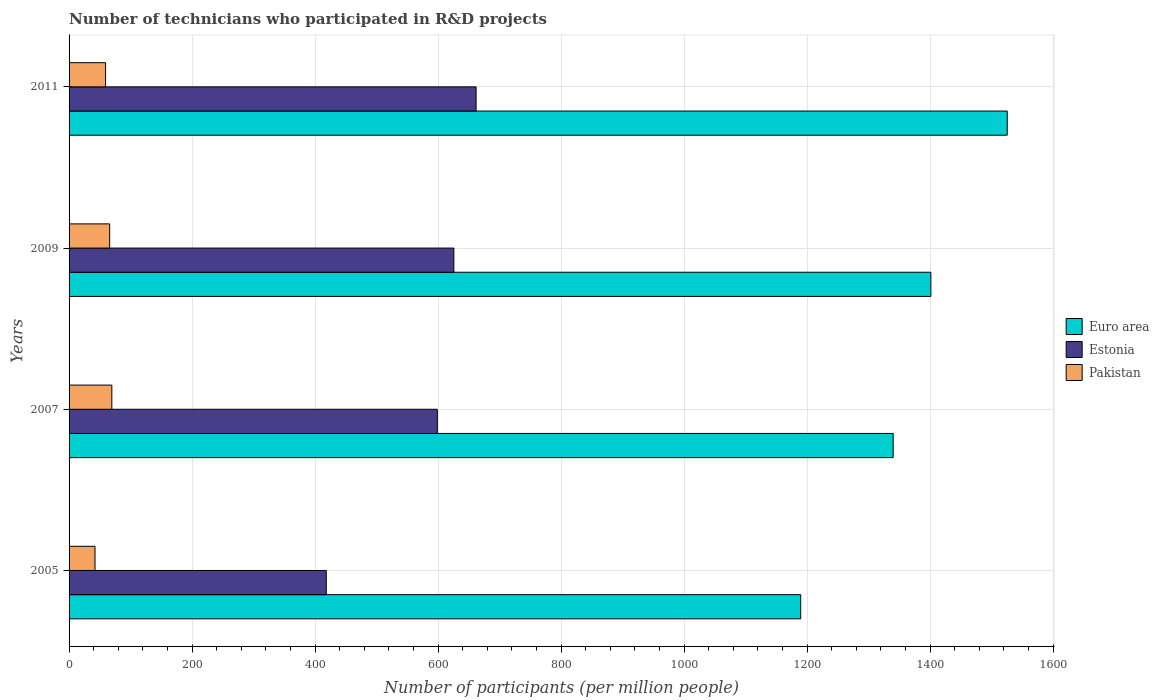How many different coloured bars are there?
Keep it short and to the point. 3. What is the label of the 4th group of bars from the top?
Keep it short and to the point. 2005. What is the number of technicians who participated in R&D projects in Euro area in 2011?
Your answer should be compact. 1525.59. Across all years, what is the maximum number of technicians who participated in R&D projects in Pakistan?
Your response must be concise. 69.56. Across all years, what is the minimum number of technicians who participated in R&D projects in Estonia?
Make the answer very short. 418.25. What is the total number of technicians who participated in R&D projects in Estonia in the graph?
Ensure brevity in your answer.  2304.71. What is the difference between the number of technicians who participated in R&D projects in Pakistan in 2007 and that in 2011?
Your response must be concise. 10.23. What is the difference between the number of technicians who participated in R&D projects in Euro area in 2009 and the number of technicians who participated in R&D projects in Pakistan in 2011?
Ensure brevity in your answer.  1342.06. What is the average number of technicians who participated in R&D projects in Pakistan per year?
Your answer should be compact. 59.27. In the year 2007, what is the difference between the number of technicians who participated in R&D projects in Pakistan and number of technicians who participated in R&D projects in Estonia?
Your response must be concise. -529.3. In how many years, is the number of technicians who participated in R&D projects in Estonia greater than 120 ?
Your answer should be very brief. 4. What is the ratio of the number of technicians who participated in R&D projects in Estonia in 2005 to that in 2011?
Make the answer very short. 0.63. Is the number of technicians who participated in R&D projects in Estonia in 2005 less than that in 2009?
Provide a succinct answer. Yes. What is the difference between the highest and the second highest number of technicians who participated in R&D projects in Euro area?
Offer a very short reply. 124.2. What is the difference between the highest and the lowest number of technicians who participated in R&D projects in Pakistan?
Keep it short and to the point. 27.36. What does the 3rd bar from the top in 2009 represents?
Provide a short and direct response. Euro area. What does the 2nd bar from the bottom in 2011 represents?
Your response must be concise. Estonia. How many years are there in the graph?
Your answer should be compact. 4. What is the difference between two consecutive major ticks on the X-axis?
Give a very brief answer. 200. Are the values on the major ticks of X-axis written in scientific E-notation?
Provide a succinct answer. No. Does the graph contain any zero values?
Give a very brief answer. No. Where does the legend appear in the graph?
Your answer should be compact. Center right. What is the title of the graph?
Make the answer very short. Number of technicians who participated in R&D projects. What is the label or title of the X-axis?
Your answer should be compact. Number of participants (per million people). What is the Number of participants (per million people) of Euro area in 2005?
Your answer should be very brief. 1189.74. What is the Number of participants (per million people) in Estonia in 2005?
Provide a succinct answer. 418.25. What is the Number of participants (per million people) of Pakistan in 2005?
Offer a terse response. 42.2. What is the Number of participants (per million people) of Euro area in 2007?
Ensure brevity in your answer.  1340.09. What is the Number of participants (per million people) of Estonia in 2007?
Your response must be concise. 598.85. What is the Number of participants (per million people) of Pakistan in 2007?
Your answer should be compact. 69.56. What is the Number of participants (per million people) of Euro area in 2009?
Provide a short and direct response. 1401.39. What is the Number of participants (per million people) of Estonia in 2009?
Make the answer very short. 625.74. What is the Number of participants (per million people) of Pakistan in 2009?
Give a very brief answer. 66.02. What is the Number of participants (per million people) in Euro area in 2011?
Your answer should be very brief. 1525.59. What is the Number of participants (per million people) in Estonia in 2011?
Give a very brief answer. 661.86. What is the Number of participants (per million people) of Pakistan in 2011?
Provide a short and direct response. 59.33. Across all years, what is the maximum Number of participants (per million people) of Euro area?
Make the answer very short. 1525.59. Across all years, what is the maximum Number of participants (per million people) in Estonia?
Keep it short and to the point. 661.86. Across all years, what is the maximum Number of participants (per million people) of Pakistan?
Provide a succinct answer. 69.56. Across all years, what is the minimum Number of participants (per million people) in Euro area?
Make the answer very short. 1189.74. Across all years, what is the minimum Number of participants (per million people) of Estonia?
Ensure brevity in your answer.  418.25. Across all years, what is the minimum Number of participants (per million people) of Pakistan?
Offer a very short reply. 42.2. What is the total Number of participants (per million people) in Euro area in the graph?
Offer a very short reply. 5456.81. What is the total Number of participants (per million people) in Estonia in the graph?
Give a very brief answer. 2304.71. What is the total Number of participants (per million people) of Pakistan in the graph?
Provide a succinct answer. 237.1. What is the difference between the Number of participants (per million people) of Euro area in 2005 and that in 2007?
Provide a succinct answer. -150.35. What is the difference between the Number of participants (per million people) in Estonia in 2005 and that in 2007?
Your response must be concise. -180.61. What is the difference between the Number of participants (per million people) of Pakistan in 2005 and that in 2007?
Provide a short and direct response. -27.36. What is the difference between the Number of participants (per million people) of Euro area in 2005 and that in 2009?
Give a very brief answer. -211.65. What is the difference between the Number of participants (per million people) in Estonia in 2005 and that in 2009?
Your response must be concise. -207.5. What is the difference between the Number of participants (per million people) of Pakistan in 2005 and that in 2009?
Provide a short and direct response. -23.82. What is the difference between the Number of participants (per million people) of Euro area in 2005 and that in 2011?
Offer a very short reply. -335.85. What is the difference between the Number of participants (per million people) of Estonia in 2005 and that in 2011?
Keep it short and to the point. -243.62. What is the difference between the Number of participants (per million people) of Pakistan in 2005 and that in 2011?
Offer a very short reply. -17.14. What is the difference between the Number of participants (per million people) of Euro area in 2007 and that in 2009?
Your answer should be compact. -61.3. What is the difference between the Number of participants (per million people) in Estonia in 2007 and that in 2009?
Offer a terse response. -26.89. What is the difference between the Number of participants (per million people) in Pakistan in 2007 and that in 2009?
Give a very brief answer. 3.54. What is the difference between the Number of participants (per million people) in Euro area in 2007 and that in 2011?
Make the answer very short. -185.49. What is the difference between the Number of participants (per million people) of Estonia in 2007 and that in 2011?
Your answer should be compact. -63.01. What is the difference between the Number of participants (per million people) of Pakistan in 2007 and that in 2011?
Provide a succinct answer. 10.23. What is the difference between the Number of participants (per million people) of Euro area in 2009 and that in 2011?
Provide a succinct answer. -124.2. What is the difference between the Number of participants (per million people) in Estonia in 2009 and that in 2011?
Your response must be concise. -36.12. What is the difference between the Number of participants (per million people) of Pakistan in 2009 and that in 2011?
Provide a short and direct response. 6.68. What is the difference between the Number of participants (per million people) of Euro area in 2005 and the Number of participants (per million people) of Estonia in 2007?
Ensure brevity in your answer.  590.88. What is the difference between the Number of participants (per million people) of Euro area in 2005 and the Number of participants (per million people) of Pakistan in 2007?
Ensure brevity in your answer.  1120.18. What is the difference between the Number of participants (per million people) of Estonia in 2005 and the Number of participants (per million people) of Pakistan in 2007?
Give a very brief answer. 348.69. What is the difference between the Number of participants (per million people) of Euro area in 2005 and the Number of participants (per million people) of Estonia in 2009?
Give a very brief answer. 564. What is the difference between the Number of participants (per million people) in Euro area in 2005 and the Number of participants (per million people) in Pakistan in 2009?
Make the answer very short. 1123.72. What is the difference between the Number of participants (per million people) of Estonia in 2005 and the Number of participants (per million people) of Pakistan in 2009?
Your answer should be very brief. 352.23. What is the difference between the Number of participants (per million people) in Euro area in 2005 and the Number of participants (per million people) in Estonia in 2011?
Give a very brief answer. 527.87. What is the difference between the Number of participants (per million people) of Euro area in 2005 and the Number of participants (per million people) of Pakistan in 2011?
Provide a succinct answer. 1130.41. What is the difference between the Number of participants (per million people) of Estonia in 2005 and the Number of participants (per million people) of Pakistan in 2011?
Keep it short and to the point. 358.91. What is the difference between the Number of participants (per million people) of Euro area in 2007 and the Number of participants (per million people) of Estonia in 2009?
Give a very brief answer. 714.35. What is the difference between the Number of participants (per million people) of Euro area in 2007 and the Number of participants (per million people) of Pakistan in 2009?
Offer a terse response. 1274.08. What is the difference between the Number of participants (per million people) in Estonia in 2007 and the Number of participants (per million people) in Pakistan in 2009?
Provide a short and direct response. 532.84. What is the difference between the Number of participants (per million people) in Euro area in 2007 and the Number of participants (per million people) in Estonia in 2011?
Ensure brevity in your answer.  678.23. What is the difference between the Number of participants (per million people) of Euro area in 2007 and the Number of participants (per million people) of Pakistan in 2011?
Give a very brief answer. 1280.76. What is the difference between the Number of participants (per million people) of Estonia in 2007 and the Number of participants (per million people) of Pakistan in 2011?
Make the answer very short. 539.52. What is the difference between the Number of participants (per million people) in Euro area in 2009 and the Number of participants (per million people) in Estonia in 2011?
Provide a succinct answer. 739.53. What is the difference between the Number of participants (per million people) of Euro area in 2009 and the Number of participants (per million people) of Pakistan in 2011?
Offer a terse response. 1342.06. What is the difference between the Number of participants (per million people) of Estonia in 2009 and the Number of participants (per million people) of Pakistan in 2011?
Ensure brevity in your answer.  566.41. What is the average Number of participants (per million people) in Euro area per year?
Give a very brief answer. 1364.2. What is the average Number of participants (per million people) in Estonia per year?
Offer a terse response. 576.18. What is the average Number of participants (per million people) in Pakistan per year?
Give a very brief answer. 59.27. In the year 2005, what is the difference between the Number of participants (per million people) of Euro area and Number of participants (per million people) of Estonia?
Offer a very short reply. 771.49. In the year 2005, what is the difference between the Number of participants (per million people) of Euro area and Number of participants (per million people) of Pakistan?
Keep it short and to the point. 1147.54. In the year 2005, what is the difference between the Number of participants (per million people) of Estonia and Number of participants (per million people) of Pakistan?
Your response must be concise. 376.05. In the year 2007, what is the difference between the Number of participants (per million people) of Euro area and Number of participants (per million people) of Estonia?
Your answer should be compact. 741.24. In the year 2007, what is the difference between the Number of participants (per million people) in Euro area and Number of participants (per million people) in Pakistan?
Provide a short and direct response. 1270.53. In the year 2007, what is the difference between the Number of participants (per million people) of Estonia and Number of participants (per million people) of Pakistan?
Your answer should be very brief. 529.3. In the year 2009, what is the difference between the Number of participants (per million people) of Euro area and Number of participants (per million people) of Estonia?
Offer a very short reply. 775.65. In the year 2009, what is the difference between the Number of participants (per million people) of Euro area and Number of participants (per million people) of Pakistan?
Make the answer very short. 1335.38. In the year 2009, what is the difference between the Number of participants (per million people) of Estonia and Number of participants (per million people) of Pakistan?
Offer a very short reply. 559.73. In the year 2011, what is the difference between the Number of participants (per million people) in Euro area and Number of participants (per million people) in Estonia?
Your answer should be very brief. 863.72. In the year 2011, what is the difference between the Number of participants (per million people) of Euro area and Number of participants (per million people) of Pakistan?
Offer a terse response. 1466.26. In the year 2011, what is the difference between the Number of participants (per million people) in Estonia and Number of participants (per million people) in Pakistan?
Provide a short and direct response. 602.53. What is the ratio of the Number of participants (per million people) of Euro area in 2005 to that in 2007?
Provide a short and direct response. 0.89. What is the ratio of the Number of participants (per million people) in Estonia in 2005 to that in 2007?
Your answer should be compact. 0.7. What is the ratio of the Number of participants (per million people) in Pakistan in 2005 to that in 2007?
Provide a succinct answer. 0.61. What is the ratio of the Number of participants (per million people) of Euro area in 2005 to that in 2009?
Make the answer very short. 0.85. What is the ratio of the Number of participants (per million people) of Estonia in 2005 to that in 2009?
Offer a terse response. 0.67. What is the ratio of the Number of participants (per million people) in Pakistan in 2005 to that in 2009?
Give a very brief answer. 0.64. What is the ratio of the Number of participants (per million people) in Euro area in 2005 to that in 2011?
Give a very brief answer. 0.78. What is the ratio of the Number of participants (per million people) of Estonia in 2005 to that in 2011?
Offer a very short reply. 0.63. What is the ratio of the Number of participants (per million people) of Pakistan in 2005 to that in 2011?
Ensure brevity in your answer.  0.71. What is the ratio of the Number of participants (per million people) of Euro area in 2007 to that in 2009?
Ensure brevity in your answer.  0.96. What is the ratio of the Number of participants (per million people) in Estonia in 2007 to that in 2009?
Ensure brevity in your answer.  0.96. What is the ratio of the Number of participants (per million people) of Pakistan in 2007 to that in 2009?
Your answer should be very brief. 1.05. What is the ratio of the Number of participants (per million people) of Euro area in 2007 to that in 2011?
Your answer should be very brief. 0.88. What is the ratio of the Number of participants (per million people) in Estonia in 2007 to that in 2011?
Make the answer very short. 0.9. What is the ratio of the Number of participants (per million people) of Pakistan in 2007 to that in 2011?
Provide a short and direct response. 1.17. What is the ratio of the Number of participants (per million people) in Euro area in 2009 to that in 2011?
Offer a terse response. 0.92. What is the ratio of the Number of participants (per million people) of Estonia in 2009 to that in 2011?
Keep it short and to the point. 0.95. What is the ratio of the Number of participants (per million people) of Pakistan in 2009 to that in 2011?
Keep it short and to the point. 1.11. What is the difference between the highest and the second highest Number of participants (per million people) in Euro area?
Offer a terse response. 124.2. What is the difference between the highest and the second highest Number of participants (per million people) in Estonia?
Keep it short and to the point. 36.12. What is the difference between the highest and the second highest Number of participants (per million people) in Pakistan?
Provide a succinct answer. 3.54. What is the difference between the highest and the lowest Number of participants (per million people) in Euro area?
Give a very brief answer. 335.85. What is the difference between the highest and the lowest Number of participants (per million people) in Estonia?
Provide a short and direct response. 243.62. What is the difference between the highest and the lowest Number of participants (per million people) of Pakistan?
Give a very brief answer. 27.36. 